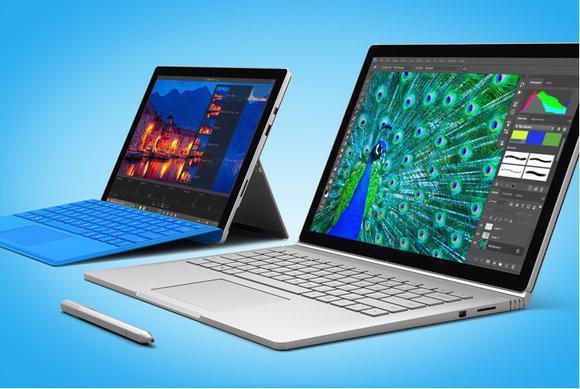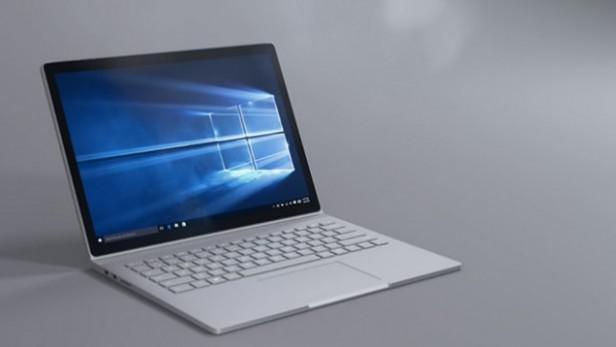The first image is the image on the left, the second image is the image on the right. Given the left and right images, does the statement "At least one image contains two open laptops, and the left image includes a laptop with a peacock displayed on its screen." hold true? Answer yes or no. Yes. The first image is the image on the left, the second image is the image on the right. Evaluate the accuracy of this statement regarding the images: "There are two computers". Is it true? Answer yes or no. No. 